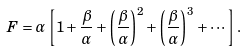Convert formula to latex. <formula><loc_0><loc_0><loc_500><loc_500>F = \alpha \left [ 1 + \frac { \beta } { \alpha } + \left ( \frac { \beta } { \alpha } \right ) ^ { 2 } + \left ( \frac { \beta } { \alpha } \right ) ^ { 3 } + \cdots \right ] .</formula> 